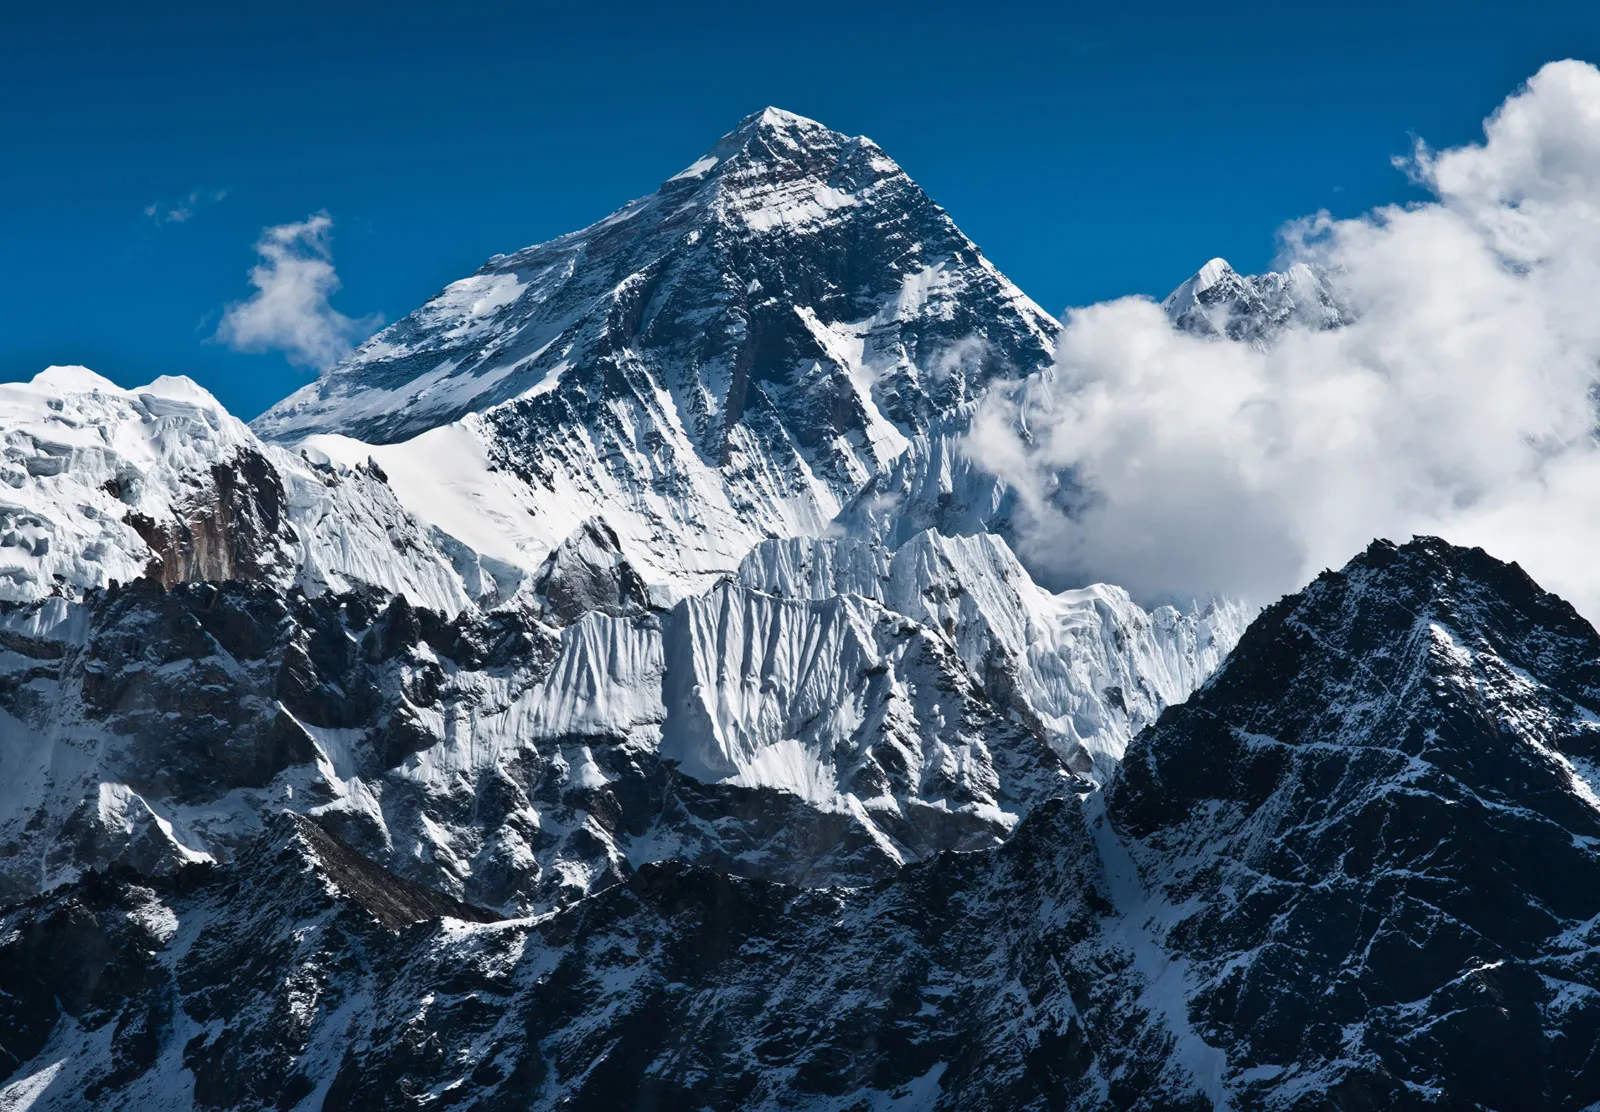Could you tell me more about the elevation and geographical significance of Mount Everest? Mount Everest, with its peak at 8,848 meters above sea level, is the world's highest mountain, a status that makes it geographically significant. It lies in the Mahalangur Himal sub-range of the Himalayas and marks a border between Nepal and the Tibet Autonomous Region of China. Everest is not only a symbol of peak mountaineering achievement but also plays a crucial role in the local and wider ecosystem, influencing weather patterns and harboring unique flora and fauna adapted to its high-altitude environment. 